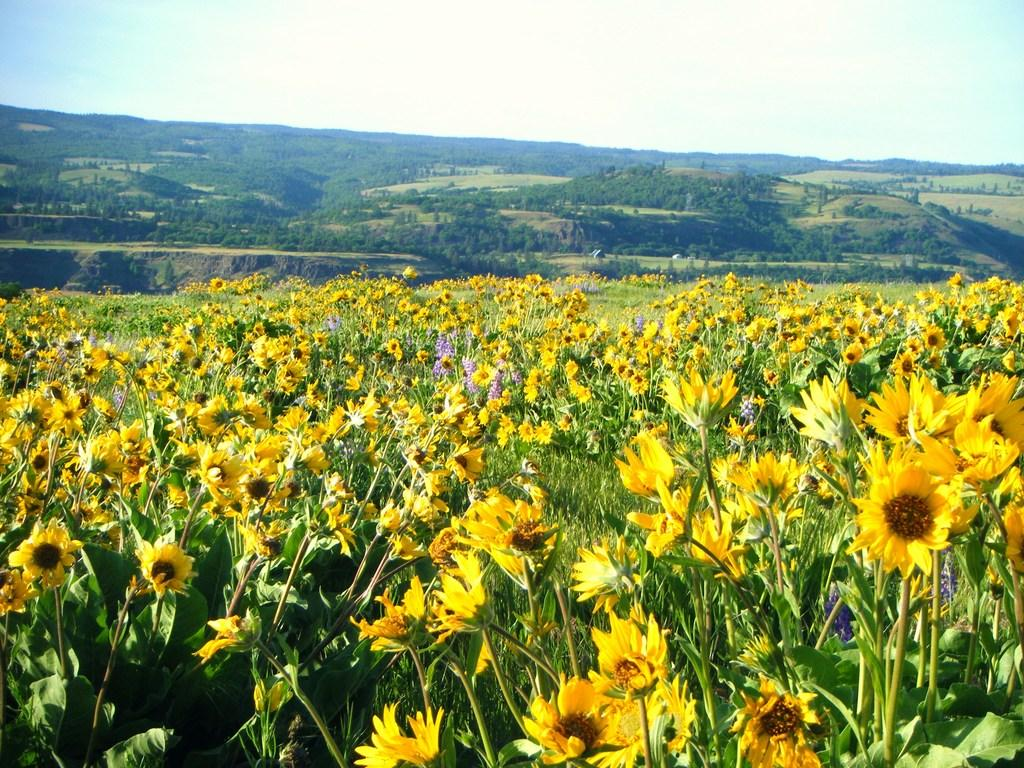What type of living organisms can be seen in the image? Plants and trees are visible in the image. What color are the flowers in the image? There are yellow flowers in the image. What can be seen in the background of the image? Trees, hills, and the sky are visible in the background of the image. Who is the owner of the copy of the book in the image? There is no book present in the image, so it is not possible to determine the owner of a copy. 